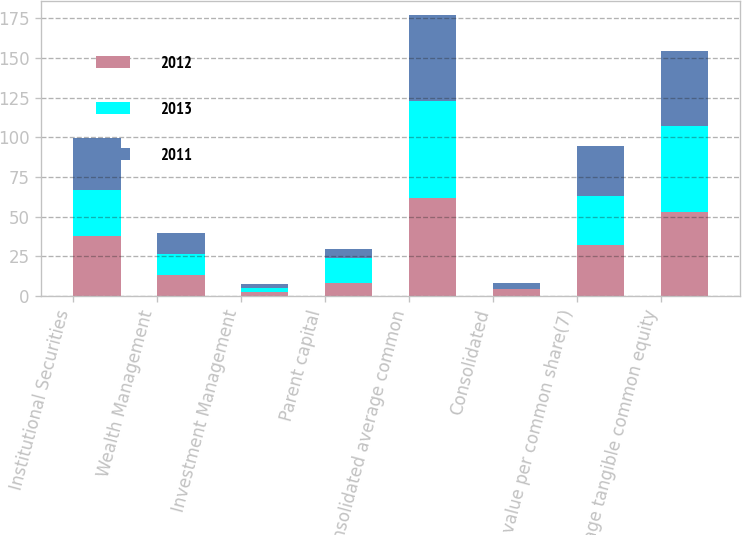Convert chart to OTSL. <chart><loc_0><loc_0><loc_500><loc_500><stacked_bar_chart><ecel><fcel>Institutional Securities<fcel>Wealth Management<fcel>Investment Management<fcel>Parent capital<fcel>Consolidated average common<fcel>Consolidated<fcel>Book value per common share(7)<fcel>Average tangible common equity<nl><fcel>2012<fcel>37.9<fcel>13.2<fcel>2.8<fcel>8<fcel>61.9<fcel>4.4<fcel>32.24<fcel>53<nl><fcel>2013<fcel>29<fcel>13.3<fcel>2.4<fcel>16.1<fcel>60.8<fcel>0.1<fcel>30.7<fcel>53.9<nl><fcel>2011<fcel>32.7<fcel>13.2<fcel>2.6<fcel>5.9<fcel>54.4<fcel>4<fcel>31.42<fcel>47.5<nl></chart> 